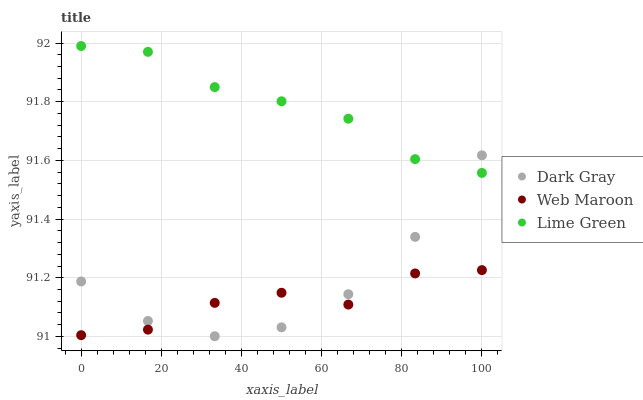Does Web Maroon have the minimum area under the curve?
Answer yes or no. Yes. Does Lime Green have the maximum area under the curve?
Answer yes or no. Yes. Does Lime Green have the minimum area under the curve?
Answer yes or no. No. Does Web Maroon have the maximum area under the curve?
Answer yes or no. No. Is Lime Green the smoothest?
Answer yes or no. Yes. Is Web Maroon the roughest?
Answer yes or no. Yes. Is Web Maroon the smoothest?
Answer yes or no. No. Is Lime Green the roughest?
Answer yes or no. No. Does Dark Gray have the lowest value?
Answer yes or no. Yes. Does Web Maroon have the lowest value?
Answer yes or no. No. Does Lime Green have the highest value?
Answer yes or no. Yes. Does Web Maroon have the highest value?
Answer yes or no. No. Is Web Maroon less than Lime Green?
Answer yes or no. Yes. Is Lime Green greater than Web Maroon?
Answer yes or no. Yes. Does Lime Green intersect Dark Gray?
Answer yes or no. Yes. Is Lime Green less than Dark Gray?
Answer yes or no. No. Is Lime Green greater than Dark Gray?
Answer yes or no. No. Does Web Maroon intersect Lime Green?
Answer yes or no. No. 